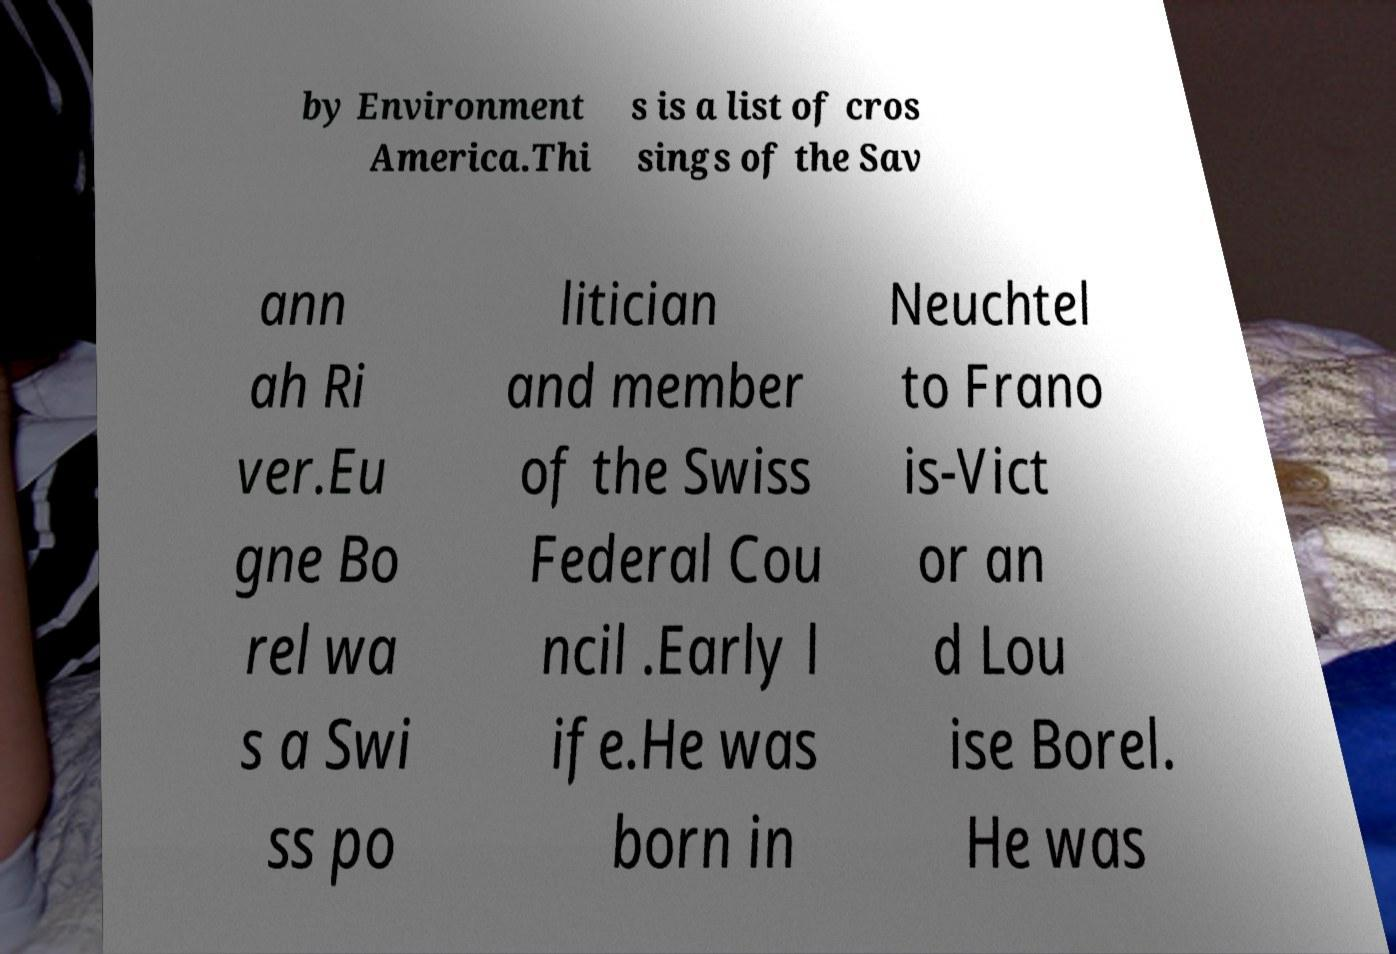Please read and relay the text visible in this image. What does it say? by Environment America.Thi s is a list of cros sings of the Sav ann ah Ri ver.Eu gne Bo rel wa s a Swi ss po litician and member of the Swiss Federal Cou ncil .Early l ife.He was born in Neuchtel to Frano is-Vict or an d Lou ise Borel. He was 